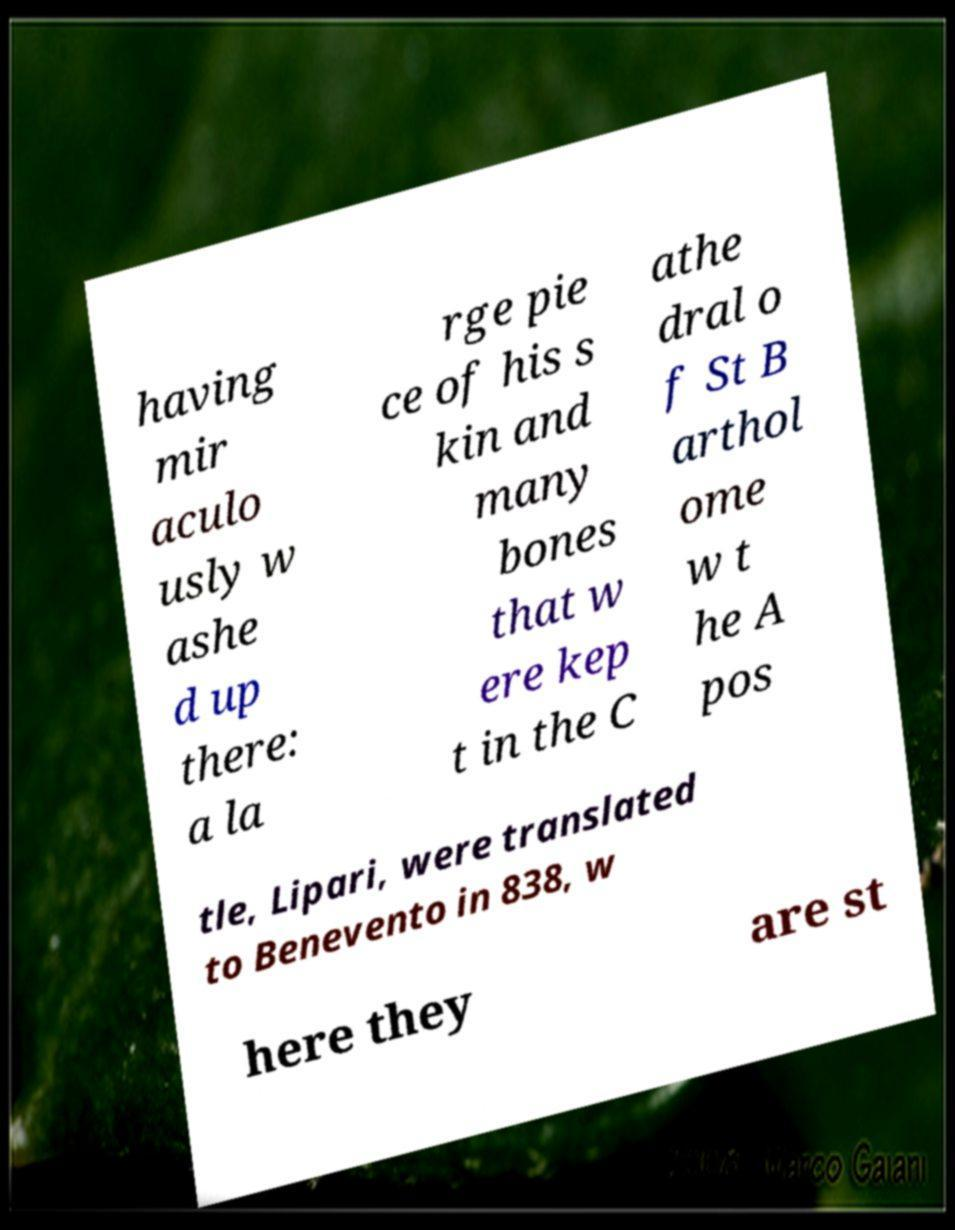Can you accurately transcribe the text from the provided image for me? having mir aculo usly w ashe d up there: a la rge pie ce of his s kin and many bones that w ere kep t in the C athe dral o f St B arthol ome w t he A pos tle, Lipari, were translated to Benevento in 838, w here they are st 